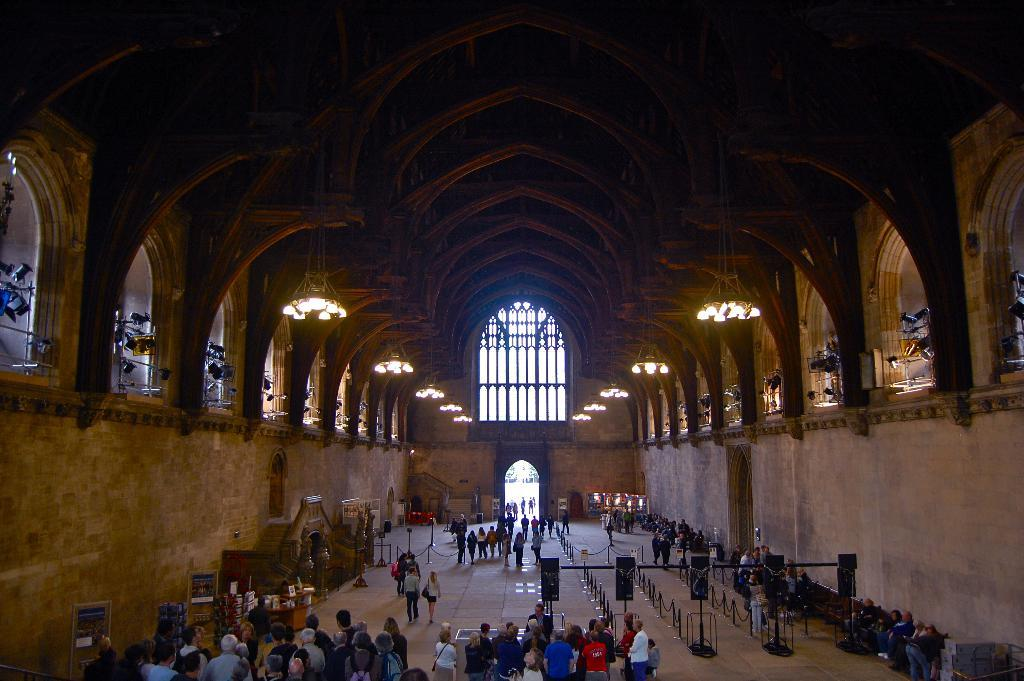What is the main subject of the image? The main subject of the image is a group of people standing. What else can be seen in the image besides the people? Sign boards, poles, fencing, lights, stairs, and a brown wall are visible in the image. What type of leather is being used to make the shoes of the birds in the image? There are no birds or shoes present in the image, so it is not possible to determine the type of leather being used. 